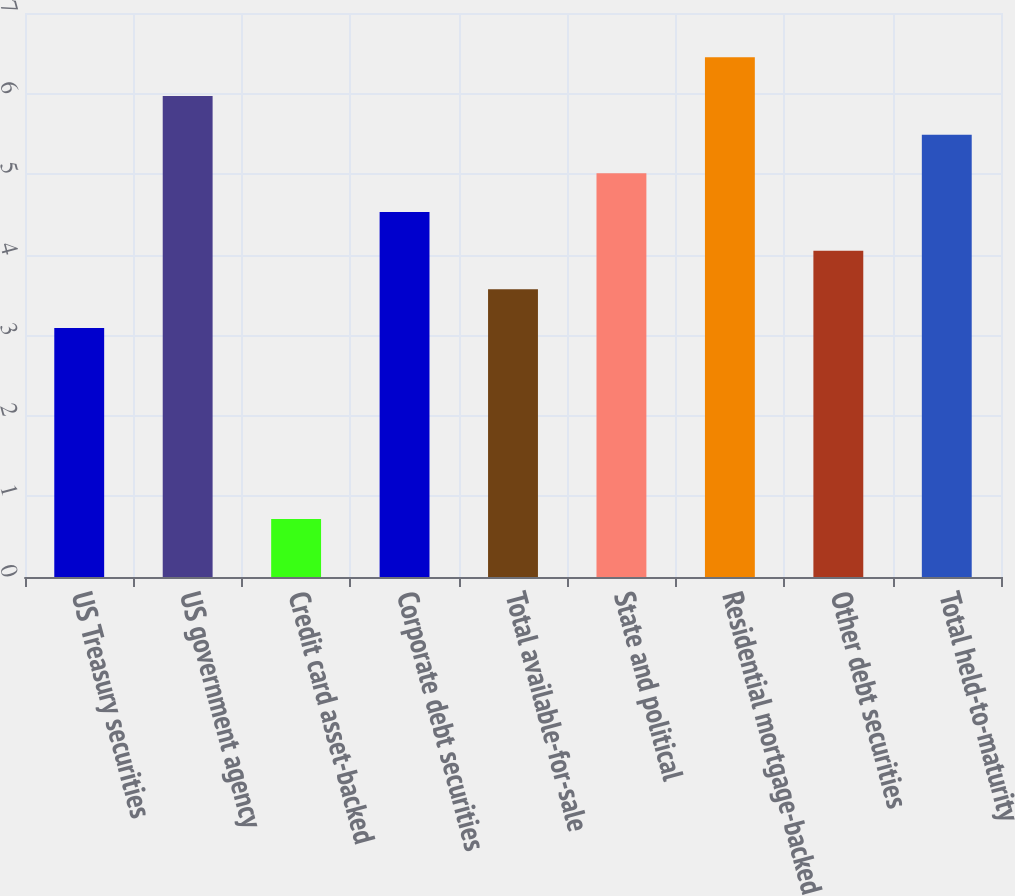Convert chart. <chart><loc_0><loc_0><loc_500><loc_500><bar_chart><fcel>US Treasury securities<fcel>US government agency<fcel>Credit card asset-backed<fcel>Corporate debt securities<fcel>Total available-for-sale<fcel>State and political<fcel>Residential mortgage-backed<fcel>Other debt securities<fcel>Total held-to-maturity<nl><fcel>3.09<fcel>5.97<fcel>0.72<fcel>4.53<fcel>3.57<fcel>5.01<fcel>6.45<fcel>4.05<fcel>5.49<nl></chart> 